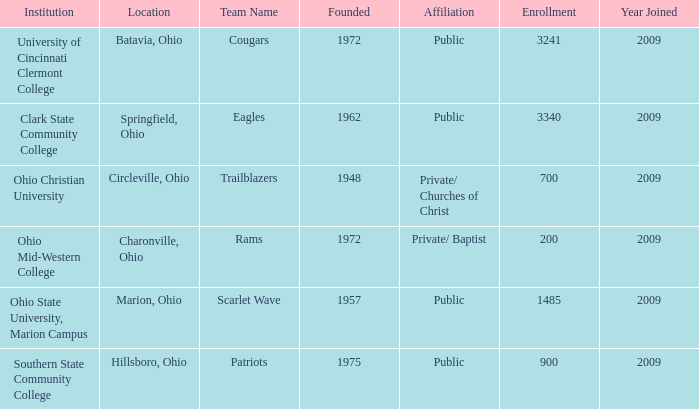What is the entity that was found in circleville, ohio? Ohio Christian University. 